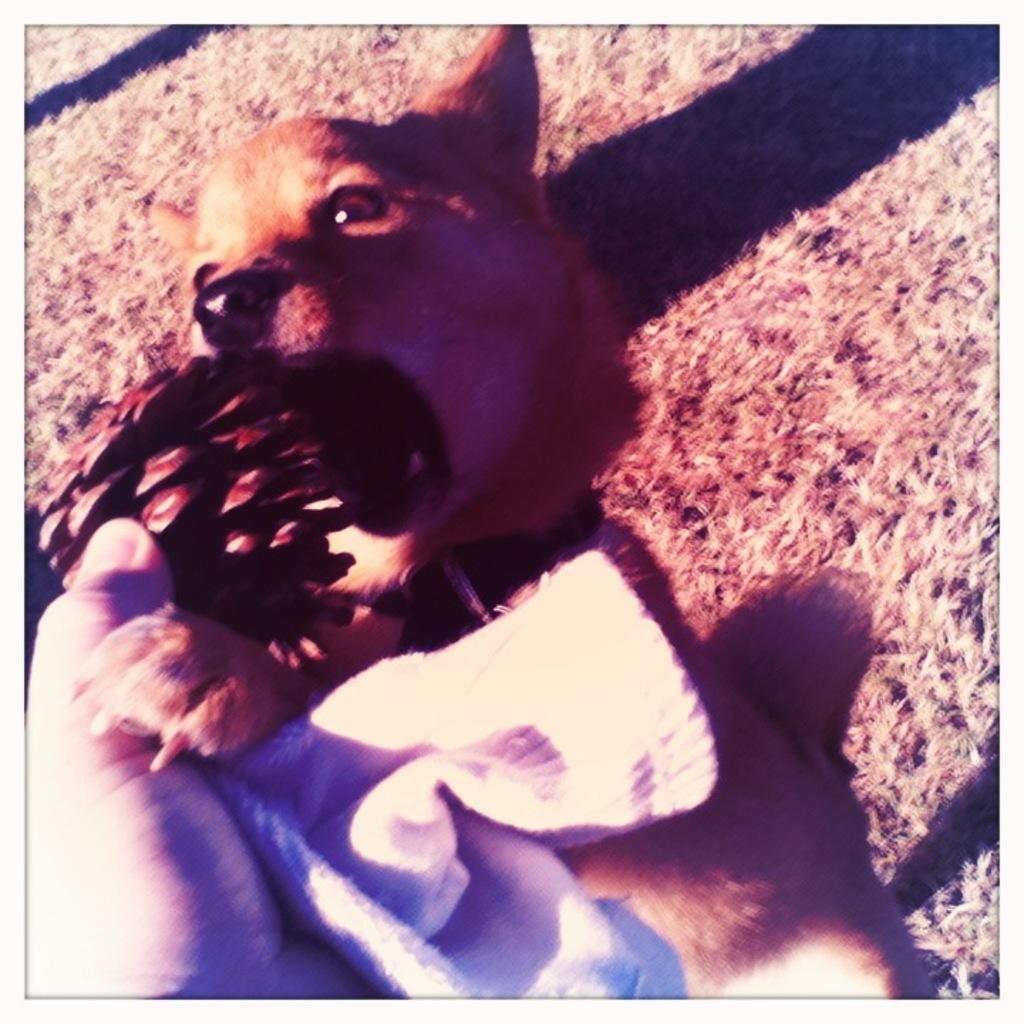What is the person holding in the image? The person is holding a cloth in the image. What type of animal can be seen in the image? There is a brown-colored dog in the image. What type of structure is the person ashamed of in the image? There is no indication of shame or any structure in the image; it only features a hand holding a cloth and a brown-colored dog. How many flies can be seen buzzing around the dog in the image? There are no flies present in the image; it only features a hand holding a cloth and a brown-colored dog. 